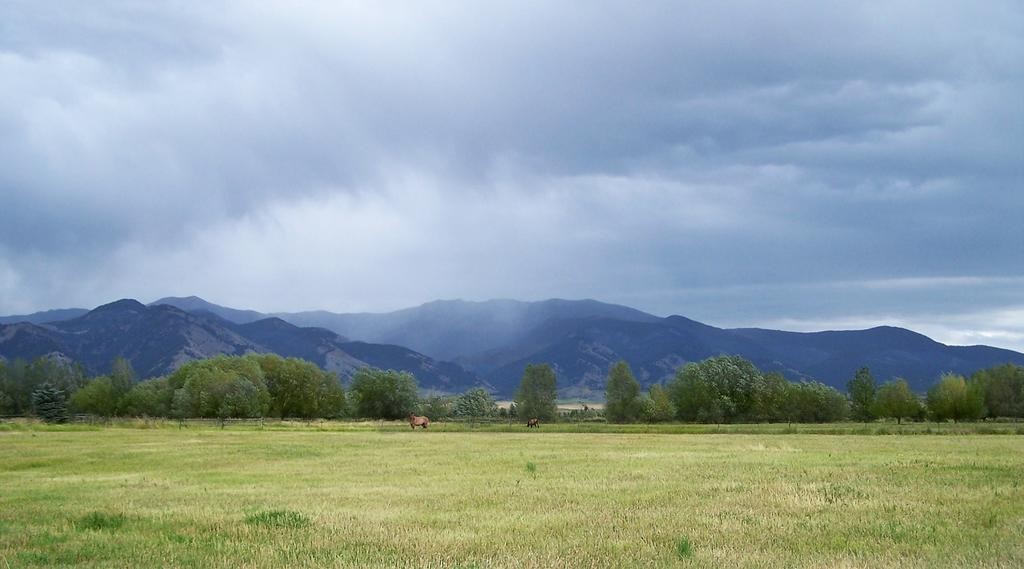What type of vegetation is present in the image? There is grass in the image. How many animals can be seen in the image? There are two animals standing in the image. What other natural elements are visible in the image? There are trees and mountains visible in the image. What is the condition of the sky in the image? There are clouds in the sky in the image. What type of whip is being used by the animals in the image? There are no whips present in the image, and the animals are not using any tools or instruments. Can you see a kite flying in the sky in the image? There is no kite visible in the sky in the image; only clouds are present. 